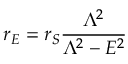<formula> <loc_0><loc_0><loc_500><loc_500>r _ { E } = r _ { S } \frac { \Lambda ^ { 2 } } { \Lambda ^ { 2 } - E ^ { 2 } }</formula> 